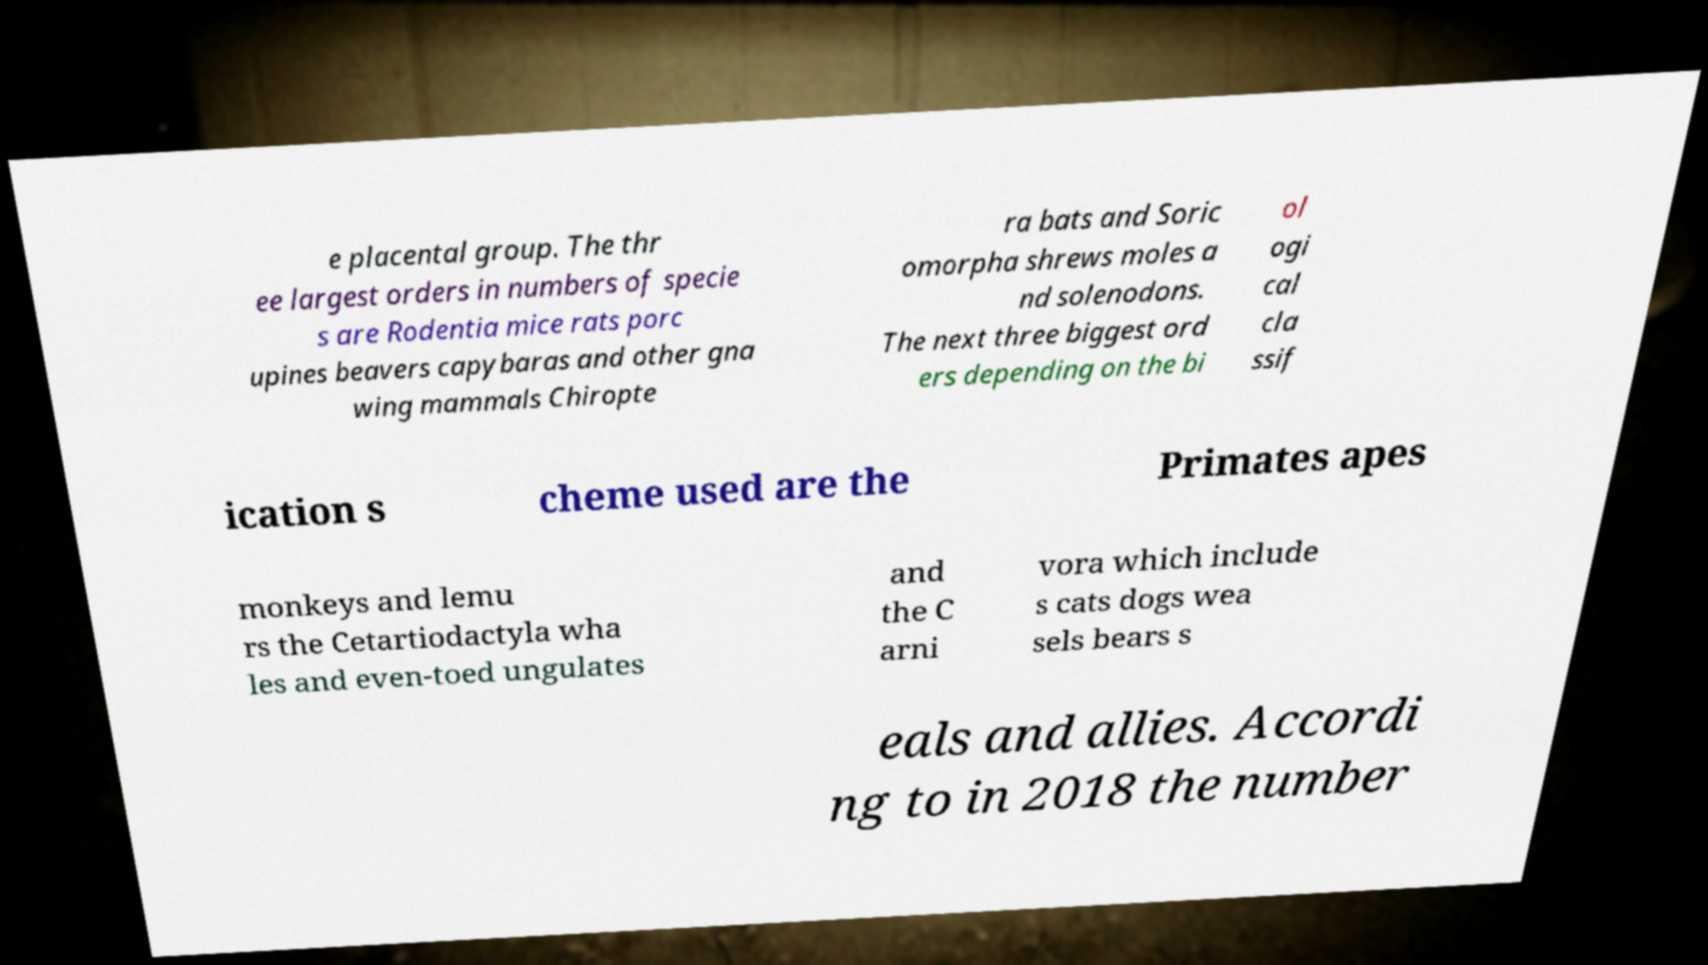Could you assist in decoding the text presented in this image and type it out clearly? e placental group. The thr ee largest orders in numbers of specie s are Rodentia mice rats porc upines beavers capybaras and other gna wing mammals Chiropte ra bats and Soric omorpha shrews moles a nd solenodons. The next three biggest ord ers depending on the bi ol ogi cal cla ssif ication s cheme used are the Primates apes monkeys and lemu rs the Cetartiodactyla wha les and even-toed ungulates and the C arni vora which include s cats dogs wea sels bears s eals and allies. Accordi ng to in 2018 the number 